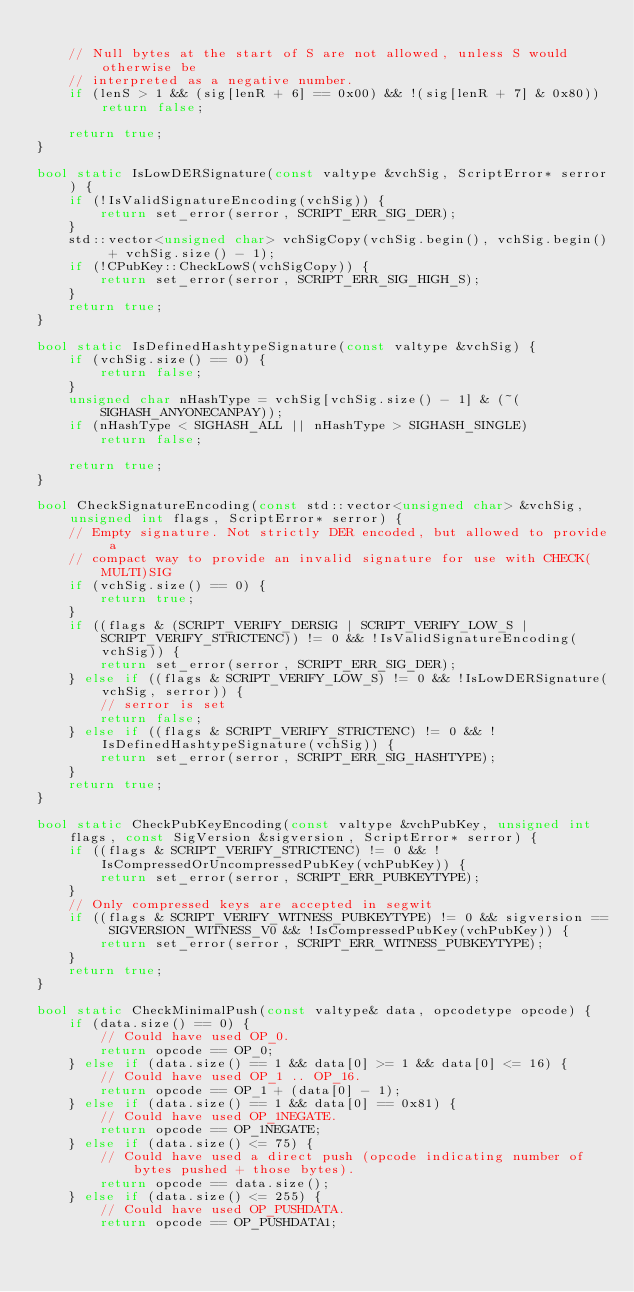<code> <loc_0><loc_0><loc_500><loc_500><_C++_>
    // Null bytes at the start of S are not allowed, unless S would otherwise be
    // interpreted as a negative number.
    if (lenS > 1 && (sig[lenR + 6] == 0x00) && !(sig[lenR + 7] & 0x80)) return false;

    return true;
}

bool static IsLowDERSignature(const valtype &vchSig, ScriptError* serror) {
    if (!IsValidSignatureEncoding(vchSig)) {
        return set_error(serror, SCRIPT_ERR_SIG_DER);
    }
    std::vector<unsigned char> vchSigCopy(vchSig.begin(), vchSig.begin() + vchSig.size() - 1);
    if (!CPubKey::CheckLowS(vchSigCopy)) {
        return set_error(serror, SCRIPT_ERR_SIG_HIGH_S);
    }
    return true;
}

bool static IsDefinedHashtypeSignature(const valtype &vchSig) {
    if (vchSig.size() == 0) {
        return false;
    }
    unsigned char nHashType = vchSig[vchSig.size() - 1] & (~(SIGHASH_ANYONECANPAY));
    if (nHashType < SIGHASH_ALL || nHashType > SIGHASH_SINGLE)
        return false;

    return true;
}

bool CheckSignatureEncoding(const std::vector<unsigned char> &vchSig, unsigned int flags, ScriptError* serror) {
    // Empty signature. Not strictly DER encoded, but allowed to provide a
    // compact way to provide an invalid signature for use with CHECK(MULTI)SIG
    if (vchSig.size() == 0) {
        return true;
    }
    if ((flags & (SCRIPT_VERIFY_DERSIG | SCRIPT_VERIFY_LOW_S | SCRIPT_VERIFY_STRICTENC)) != 0 && !IsValidSignatureEncoding(vchSig)) {
        return set_error(serror, SCRIPT_ERR_SIG_DER);
    } else if ((flags & SCRIPT_VERIFY_LOW_S) != 0 && !IsLowDERSignature(vchSig, serror)) {
        // serror is set
        return false;
    } else if ((flags & SCRIPT_VERIFY_STRICTENC) != 0 && !IsDefinedHashtypeSignature(vchSig)) {
        return set_error(serror, SCRIPT_ERR_SIG_HASHTYPE);
    }
    return true;
}

bool static CheckPubKeyEncoding(const valtype &vchPubKey, unsigned int flags, const SigVersion &sigversion, ScriptError* serror) {
    if ((flags & SCRIPT_VERIFY_STRICTENC) != 0 && !IsCompressedOrUncompressedPubKey(vchPubKey)) {
        return set_error(serror, SCRIPT_ERR_PUBKEYTYPE);
    }
    // Only compressed keys are accepted in segwit
    if ((flags & SCRIPT_VERIFY_WITNESS_PUBKEYTYPE) != 0 && sigversion == SIGVERSION_WITNESS_V0 && !IsCompressedPubKey(vchPubKey)) {
        return set_error(serror, SCRIPT_ERR_WITNESS_PUBKEYTYPE);
    }
    return true;
}

bool static CheckMinimalPush(const valtype& data, opcodetype opcode) {
    if (data.size() == 0) {
        // Could have used OP_0.
        return opcode == OP_0;
    } else if (data.size() == 1 && data[0] >= 1 && data[0] <= 16) {
        // Could have used OP_1 .. OP_16.
        return opcode == OP_1 + (data[0] - 1);
    } else if (data.size() == 1 && data[0] == 0x81) {
        // Could have used OP_1NEGATE.
        return opcode == OP_1NEGATE;
    } else if (data.size() <= 75) {
        // Could have used a direct push (opcode indicating number of bytes pushed + those bytes).
        return opcode == data.size();
    } else if (data.size() <= 255) {
        // Could have used OP_PUSHDATA.
        return opcode == OP_PUSHDATA1;</code> 